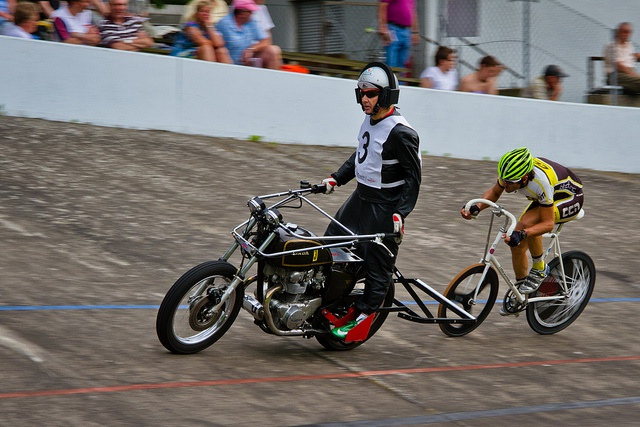Describe the objects in this image and their specific colors. I can see motorcycle in blue, black, gray, and darkgray tones, people in blue, black, darkgray, and lightgray tones, bicycle in blue, black, gray, and darkgray tones, people in blue, black, maroon, gray, and darkgray tones, and people in blue, brown, maroon, and gray tones in this image. 